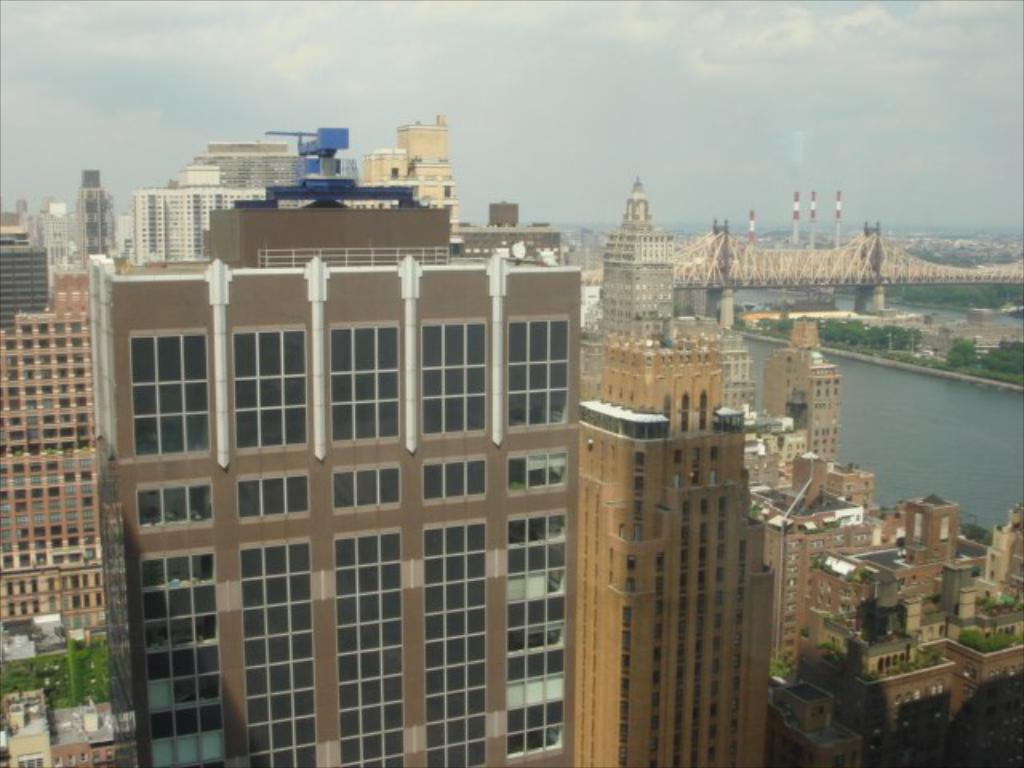What type of structures are present in the image? There are buildings with walls and buildings with glass in the image. What other types of structures can be seen in the image? There are houses, a bridge, poles, and pillars in the image. What natural elements are present in the image? There are trees, water, and the sky visible in the image. What type of crate is floating on the water in the image? There is no crate present in the image; it features buildings, houses, a bridge, poles, pillars, trees, water, and the sky. What is the weight of the vessel that is sailing on the water in the image? There is no vessel sailing on the water in the image; it only shows buildings, houses, a bridge, poles, pillars, trees, water, and the sky. 